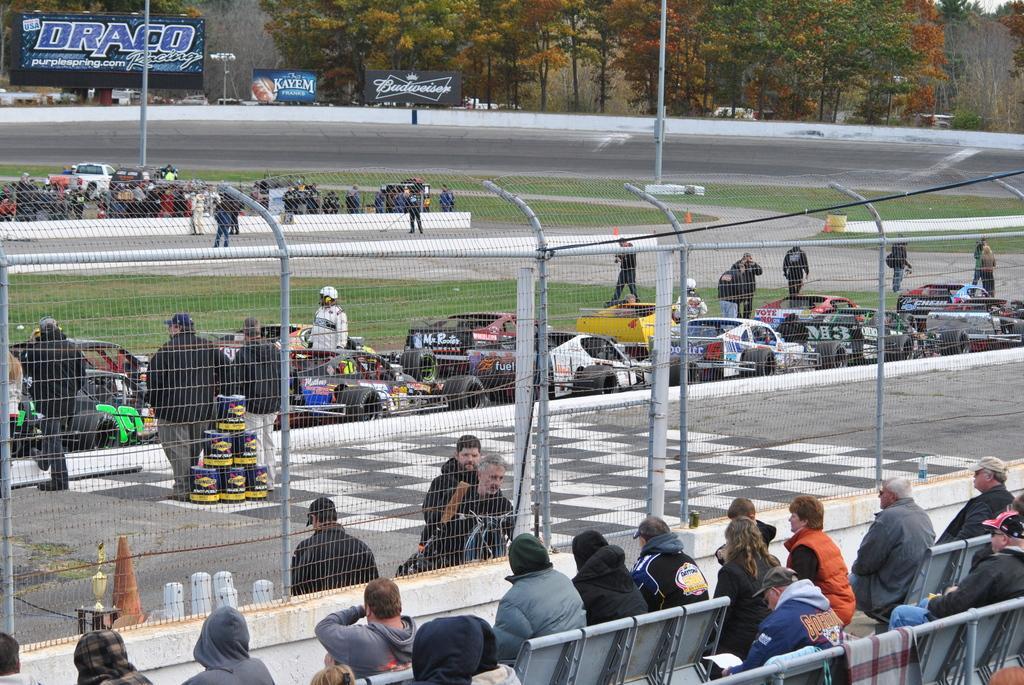Please provide a concise description of this image. In this image we can see these people are sitting on the chairs, we can see the fence, cup, road cone, these people standing, cars on the grass, a few more people here, we can see the poles, boards and the trees in the background. 